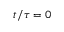Convert formula to latex. <formula><loc_0><loc_0><loc_500><loc_500>t / \tau = 0</formula> 